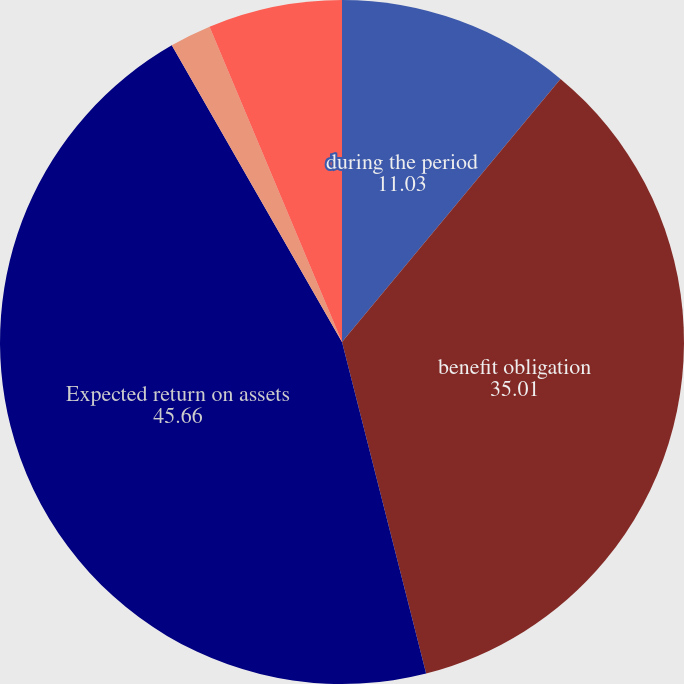Convert chart. <chart><loc_0><loc_0><loc_500><loc_500><pie_chart><fcel>during the period<fcel>benefit obligation<fcel>Expected return on assets<fcel>Amortization of prior service<fcel>Net pension cost (income)<nl><fcel>11.03%<fcel>35.01%<fcel>45.66%<fcel>1.96%<fcel>6.33%<nl></chart> 